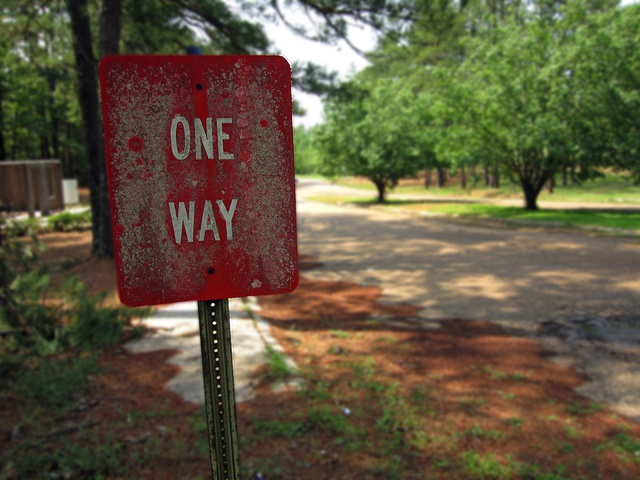Describe the objects in this image and their specific colors. I can see various objects in this image with different colors. 